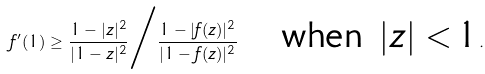<formula> <loc_0><loc_0><loc_500><loc_500>f ^ { \prime } ( 1 ) \geq \frac { 1 - | z | ^ { 2 } } { | 1 - z | ^ { 2 } } \Big / \frac { 1 - | f ( z ) | ^ { 2 } } { | 1 - f ( z ) | ^ { 2 } } \quad \text {when $|z|<1$} .</formula> 